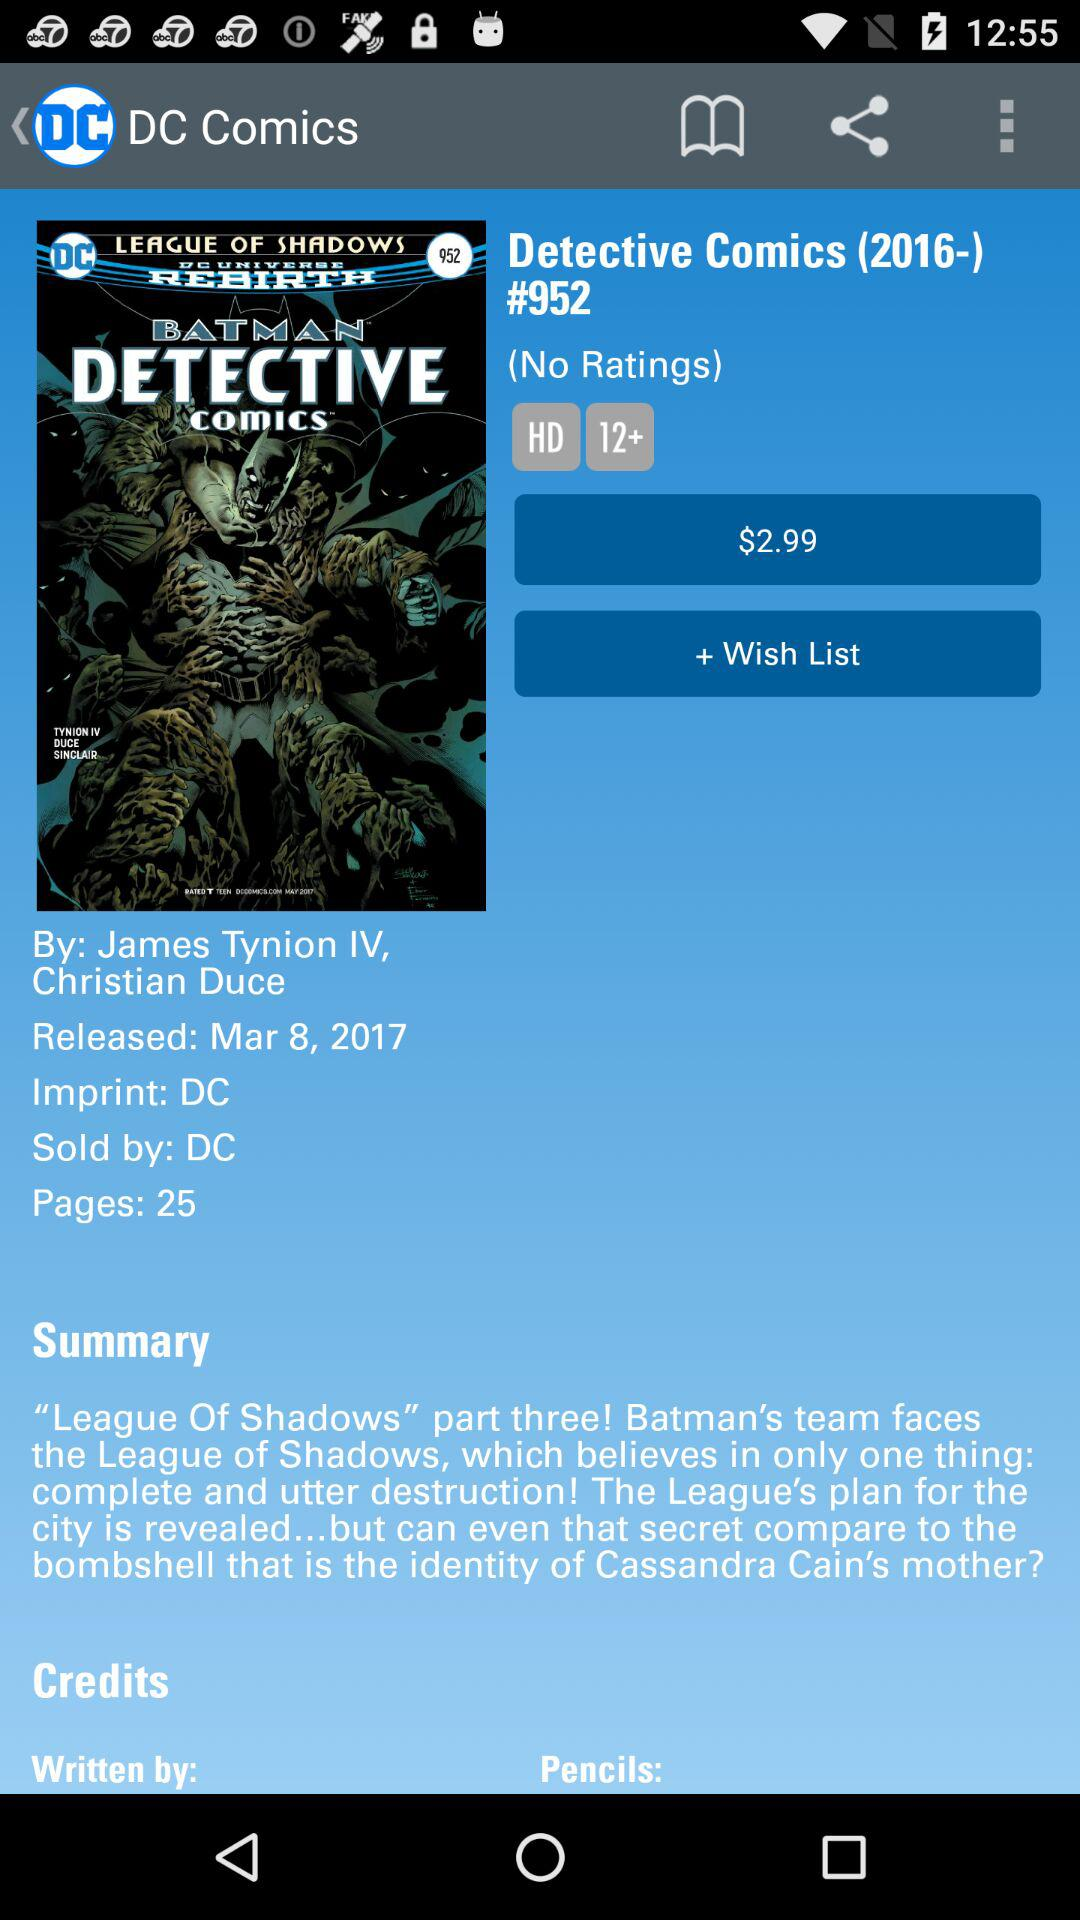What is the title of the comic? The title of the comic is "Detective Comics (2016-) #952". 